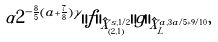Convert formula to latex. <formula><loc_0><loc_0><loc_500><loc_500>\alpha 2 ^ { - \frac { 8 } { 5 } ( a + \frac { 7 } { 8 } ) \gamma } \| f \| _ { \hat { X } _ { ( 2 , 1 ) } ^ { s , 1 / 2 } } \| g \| _ { \hat { X } _ { L } ^ { a , 3 a / 5 + 9 / 1 0 } } ,</formula> 